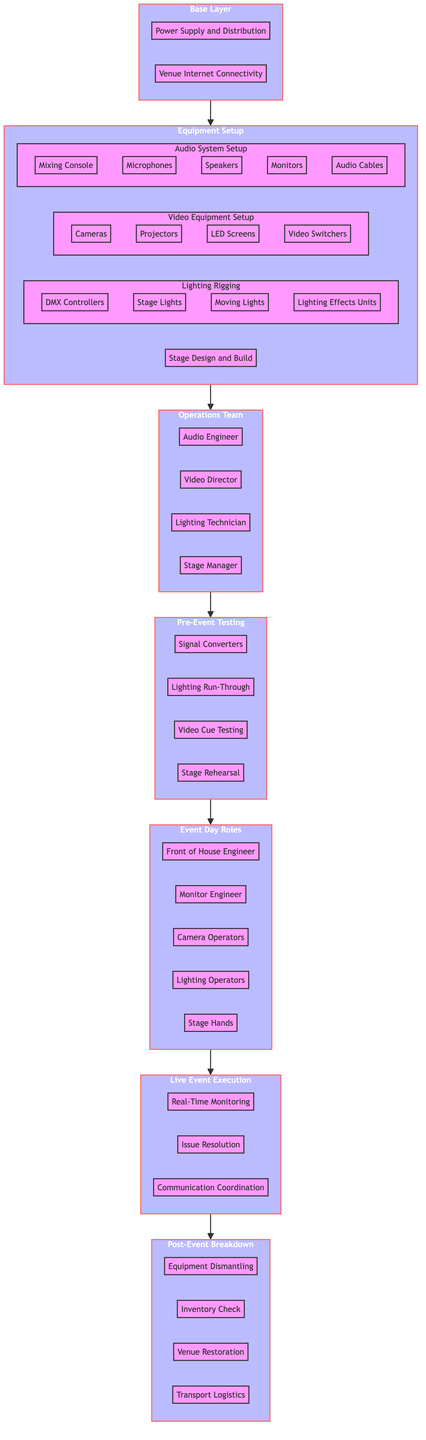What is the first stage in the flow chart? The flow chart starts with the Base Layer at the bottom, which is represented as the first stage.
Answer: Base Layer How many components are listed under the Equipment Setup stage? Under the Equipment Setup stage, there are four components listed: Audio System Setup, Video Equipment Setup, Lighting Rigging, and Stage Design and Build.
Answer: 4 What role is positioned directly above the Operations Team? The Operations Team is directly below the Pre-Event Testing stage in the flow chart.
Answer: Pre-Event Testing Which stage includes the components "Mixing Console" and "Microphones"? The components "Mixing Console" and "Microphones" are listed under the Audio System Setup stage.
Answer: Audio System Setup What is the last stage resulting from the Live Event Execution? The last stage that follows the Live Event Execution in the flow chart is the Post-Event Breakdown stage.
Answer: Post-Event Breakdown How many total stages are there in the diagram? There are eight distinct stages presented in the overall flow chart, starting from Base Layer to Post-Event Breakdown.
Answer: 8 Which component is part of the Lighting Rigging stage? The component "DMX Controllers" is specifically part of the Lighting Rigging stage.
Answer: DMX Controllers In which stage would "Sound Check" occur? "Sound Check" occurs within the Pre-Event Testing stage of the flow chart.
Answer: Pre-Event Testing Who is above the Front of House Engineer? The Front of House Engineer is part of the Event Day Roles stage, positioned above this role is the Live Event Execution stage.
Answer: Live Event Execution 